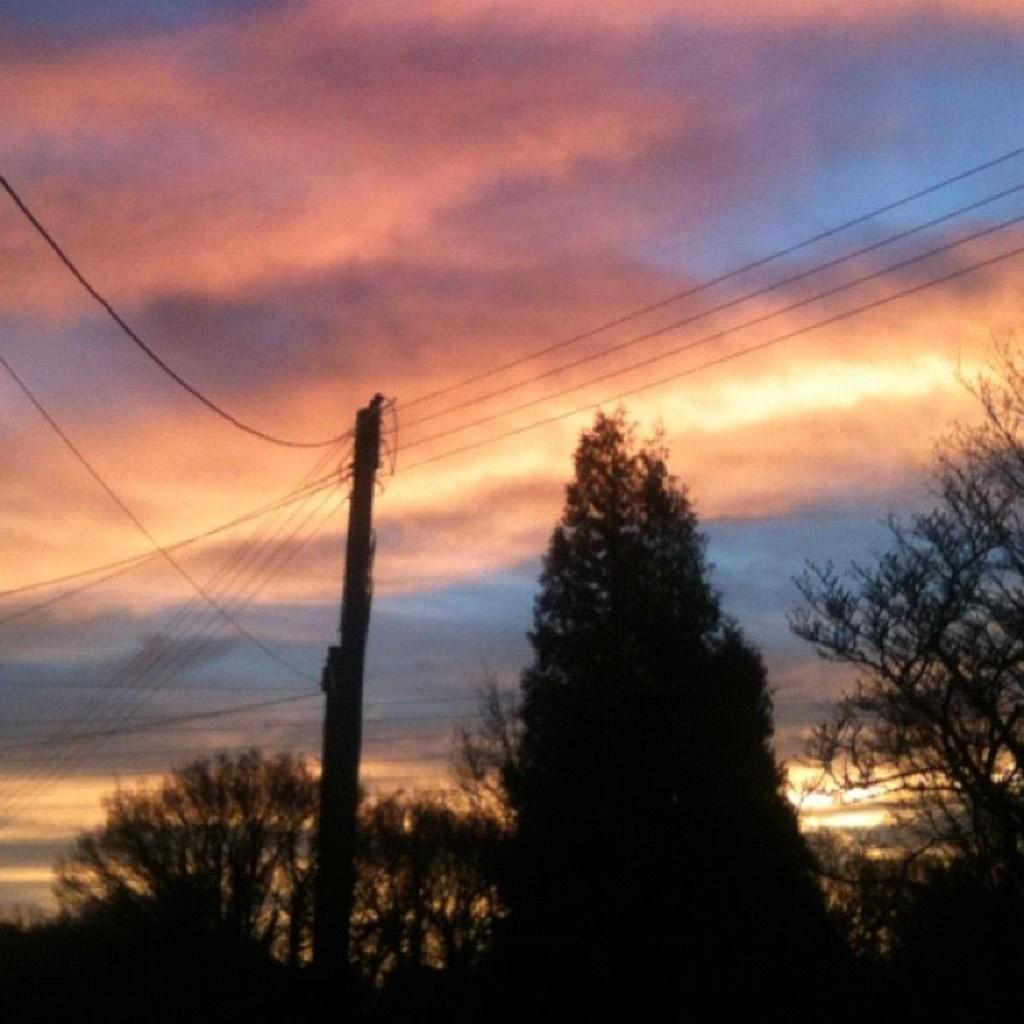Could you give a brief overview of what you see in this image? In this picture there are trees and there is a pole and there are wires on the pole. At the top there is sky and there are clouds and there is a sunlight. 